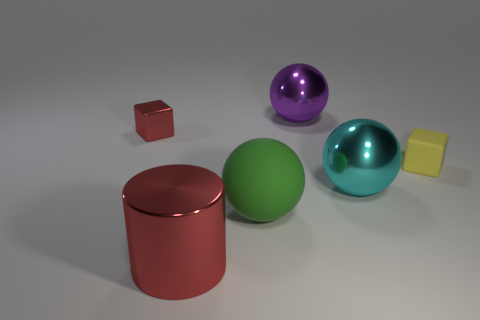The cyan thing that is the same shape as the big purple thing is what size?
Offer a terse response. Large. There is a metal thing that is both on the right side of the large red cylinder and in front of the small yellow matte object; what is its size?
Offer a terse response. Large. There is a green thing; are there any big cylinders behind it?
Your answer should be compact. No. What number of objects are metallic spheres that are in front of the tiny metal block or big blue matte cylinders?
Offer a terse response. 1. How many shiny balls are behind the big shiny object that is on the right side of the purple metal sphere?
Make the answer very short. 1. Are there fewer big red things that are behind the tiny yellow cube than green matte balls that are right of the big cyan metallic ball?
Provide a succinct answer. No. There is a matte object that is in front of the small cube that is to the right of the red cube; what shape is it?
Keep it short and to the point. Sphere. How many other things are there of the same material as the green ball?
Your response must be concise. 1. Is the number of objects greater than the number of yellow shiny spheres?
Provide a short and direct response. Yes. How big is the shiny thing that is on the left side of the red thing in front of the metal ball that is in front of the shiny cube?
Ensure brevity in your answer.  Small. 